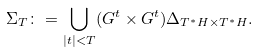Convert formula to latex. <formula><loc_0><loc_0><loc_500><loc_500>\Sigma _ { T } \colon = \bigcup _ { | t | < T } ( G ^ { t } \times G ^ { t } ) \Delta _ { T ^ { * } H \times T ^ { * } H } .</formula> 